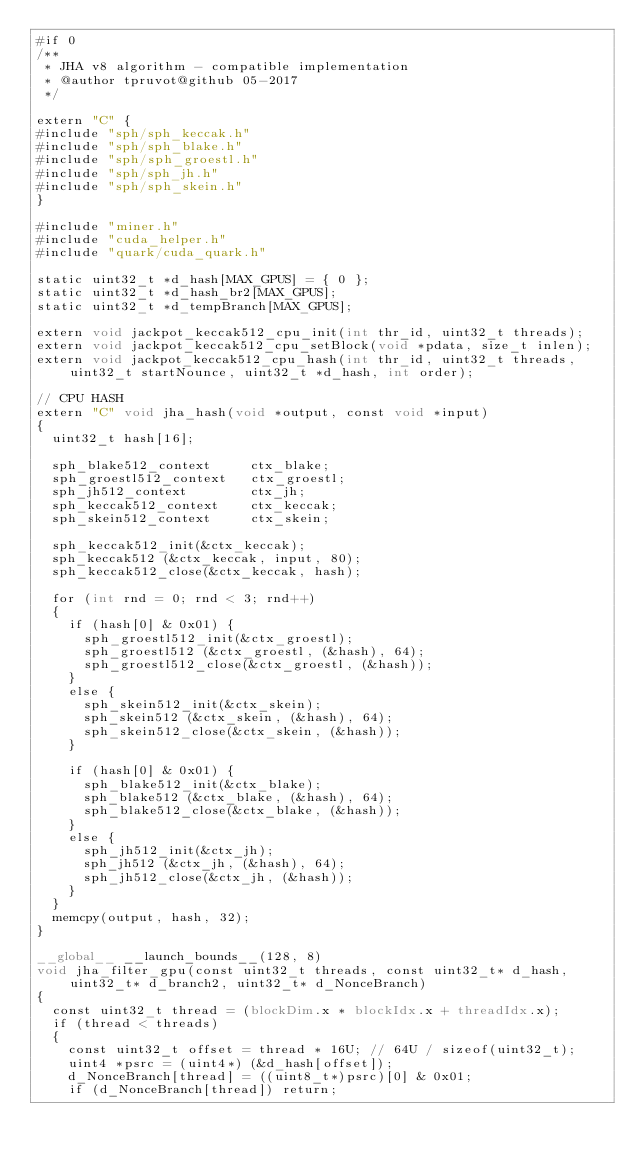Convert code to text. <code><loc_0><loc_0><loc_500><loc_500><_Cuda_>#if 0
/**
 * JHA v8 algorithm - compatible implementation
 * @author tpruvot@github 05-2017
 */

extern "C" {
#include "sph/sph_keccak.h"
#include "sph/sph_blake.h"
#include "sph/sph_groestl.h"
#include "sph/sph_jh.h"
#include "sph/sph_skein.h"
}

#include "miner.h"
#include "cuda_helper.h"
#include "quark/cuda_quark.h"

static uint32_t *d_hash[MAX_GPUS] = { 0 };
static uint32_t *d_hash_br2[MAX_GPUS];
static uint32_t *d_tempBranch[MAX_GPUS];

extern void jackpot_keccak512_cpu_init(int thr_id, uint32_t threads);
extern void jackpot_keccak512_cpu_setBlock(void *pdata, size_t inlen);
extern void jackpot_keccak512_cpu_hash(int thr_id, uint32_t threads, uint32_t startNounce, uint32_t *d_hash, int order);

// CPU HASH
extern "C" void jha_hash(void *output, const void *input)
{
	uint32_t hash[16];

	sph_blake512_context     ctx_blake;
	sph_groestl512_context   ctx_groestl;
	sph_jh512_context        ctx_jh;
	sph_keccak512_context    ctx_keccak;
	sph_skein512_context     ctx_skein;

	sph_keccak512_init(&ctx_keccak);
	sph_keccak512 (&ctx_keccak, input, 80);
	sph_keccak512_close(&ctx_keccak, hash);

	for (int rnd = 0; rnd < 3; rnd++)
	{
		if (hash[0] & 0x01) {
			sph_groestl512_init(&ctx_groestl);
			sph_groestl512 (&ctx_groestl, (&hash), 64);
			sph_groestl512_close(&ctx_groestl, (&hash));
		}
		else {
			sph_skein512_init(&ctx_skein);
			sph_skein512 (&ctx_skein, (&hash), 64);
			sph_skein512_close(&ctx_skein, (&hash));
		}

		if (hash[0] & 0x01) {
			sph_blake512_init(&ctx_blake);
			sph_blake512 (&ctx_blake, (&hash), 64);
			sph_blake512_close(&ctx_blake, (&hash));
		}
		else {
			sph_jh512_init(&ctx_jh);
			sph_jh512 (&ctx_jh, (&hash), 64);
			sph_jh512_close(&ctx_jh, (&hash));
		}
	}
	memcpy(output, hash, 32);
}

__global__ __launch_bounds__(128, 8)
void jha_filter_gpu(const uint32_t threads, const uint32_t* d_hash, uint32_t* d_branch2, uint32_t* d_NonceBranch)
{
	const uint32_t thread = (blockDim.x * blockIdx.x + threadIdx.x);
	if (thread < threads)
	{
		const uint32_t offset = thread * 16U; // 64U / sizeof(uint32_t);
		uint4 *psrc = (uint4*) (&d_hash[offset]);
		d_NonceBranch[thread] = ((uint8_t*)psrc)[0] & 0x01;
		if (d_NonceBranch[thread]) return;</code> 